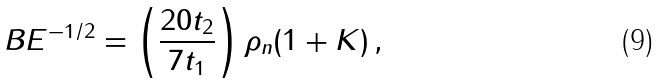Convert formula to latex. <formula><loc_0><loc_0><loc_500><loc_500>B E ^ { - 1 / 2 } = \left ( \frac { 2 0 t _ { 2 } } { 7 t _ { 1 } } \right ) \rho _ { n } ( 1 + K ) \, ,</formula> 